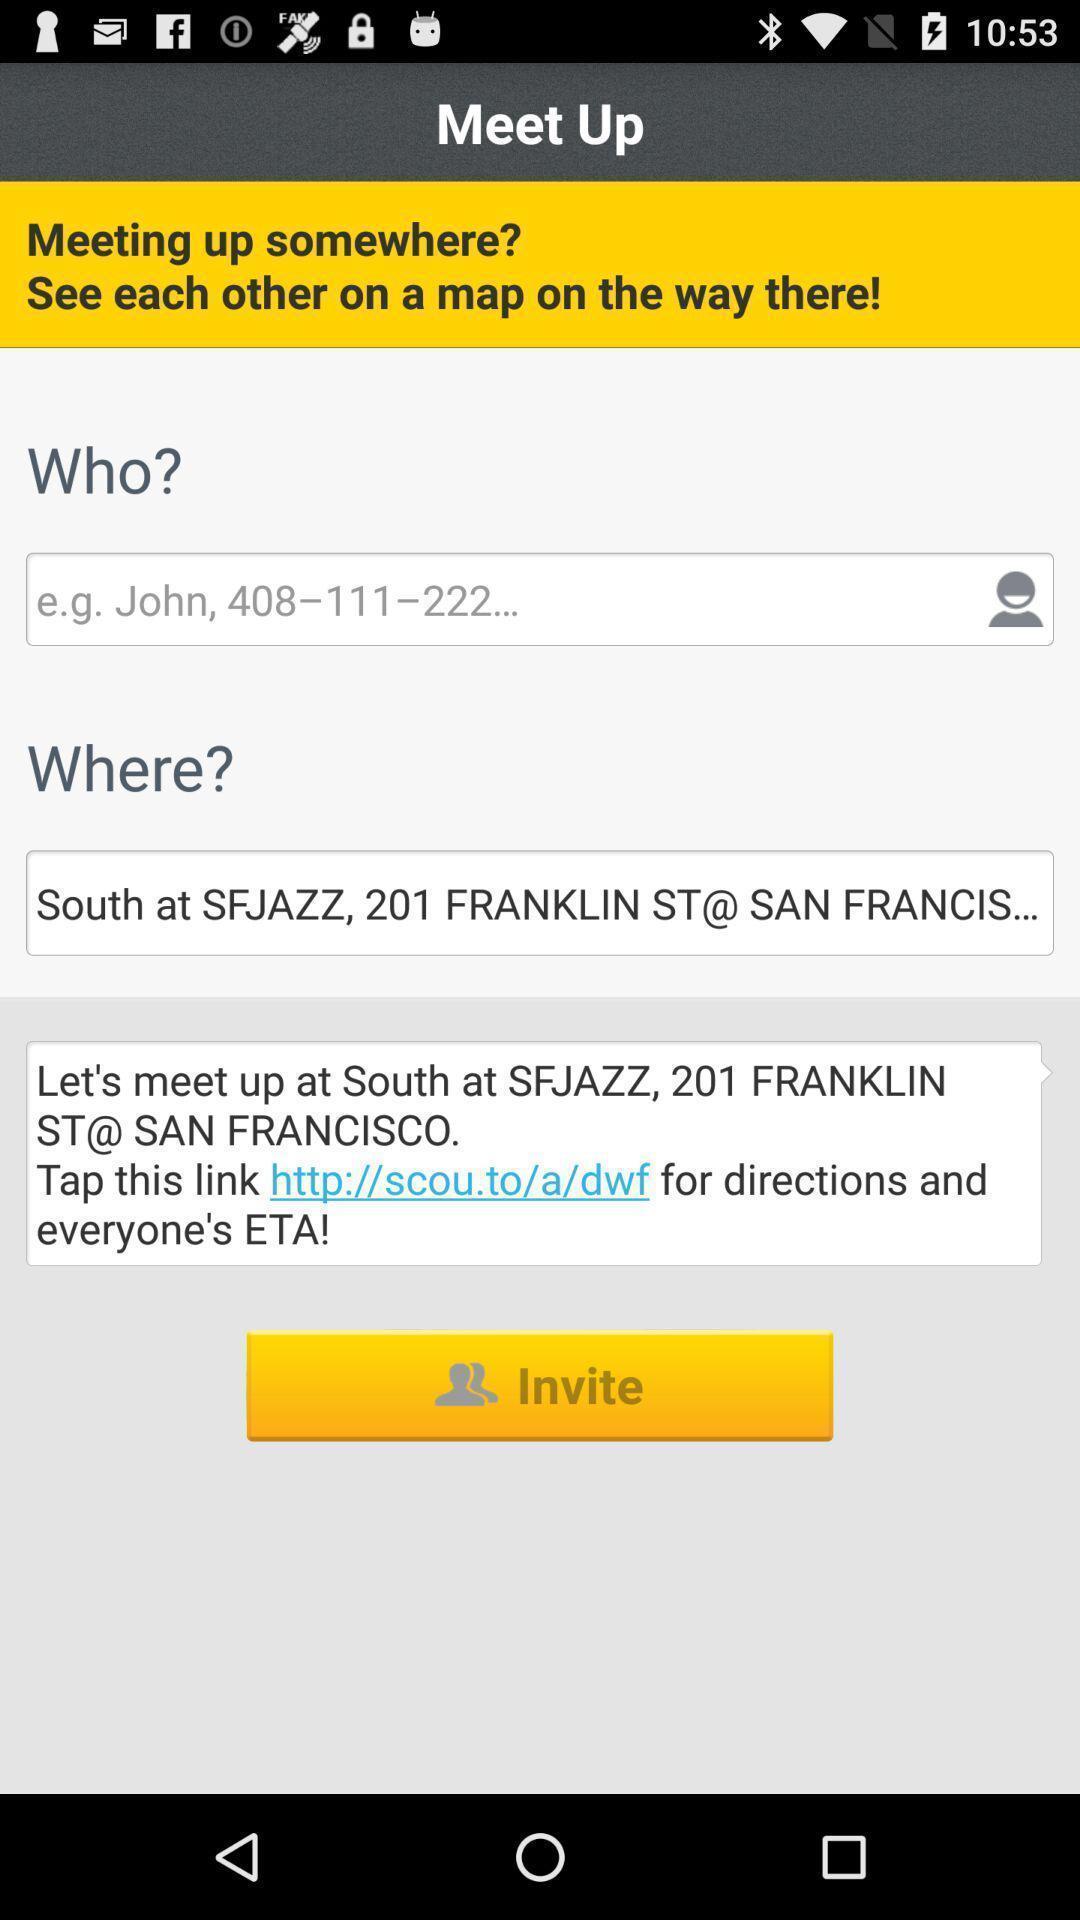Explain the elements present in this screenshot. Page displaying for social application. 